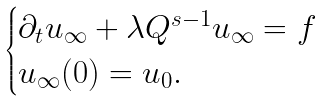<formula> <loc_0><loc_0><loc_500><loc_500>\begin{cases} \partial _ { t } u _ { \infty } + \lambda Q ^ { s - 1 } u _ { \infty } = f \\ u _ { \infty } ( 0 ) = u _ { 0 } . \end{cases}</formula> 